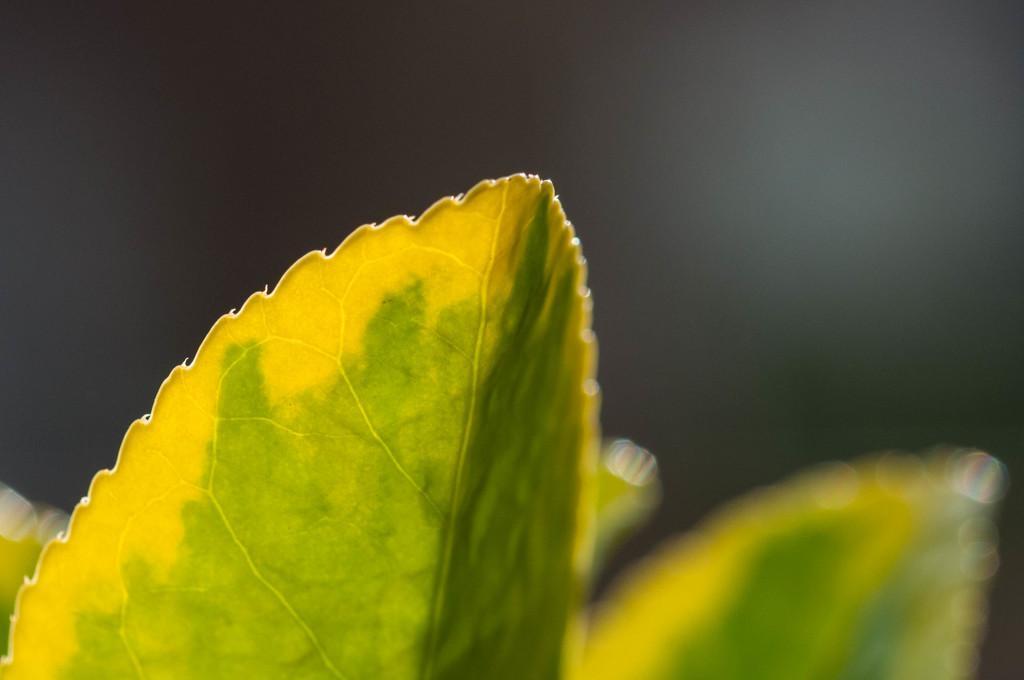In one or two sentences, can you explain what this image depicts? In this picture there are leaves and the background area of the image is blur. 